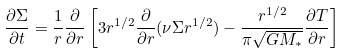Convert formula to latex. <formula><loc_0><loc_0><loc_500><loc_500>\frac { \partial \Sigma } { \partial t } = \frac { 1 } { r } \frac { \partial } { \partial r } \left [ 3 r ^ { 1 / 2 } \frac { \partial } { \partial r } ( \nu \Sigma r ^ { 1 / 2 } ) - \frac { r ^ { 1 / 2 } } { \pi \sqrt { G M _ { * } } } \frac { \partial T } { \partial r } \right ]</formula> 